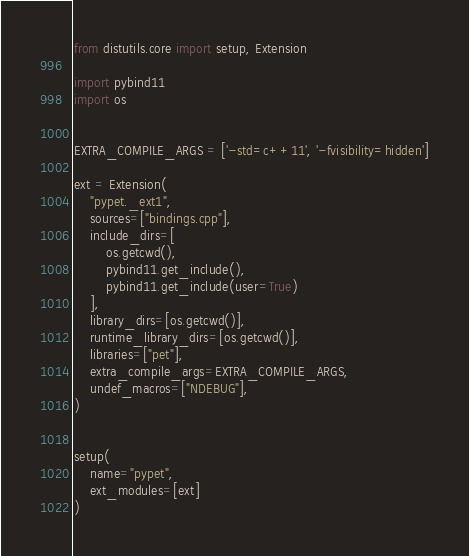Convert code to text. <code><loc_0><loc_0><loc_500><loc_500><_Python_>from distutils.core import setup, Extension

import pybind11
import os


EXTRA_COMPILE_ARGS = ['-std=c++11', '-fvisibility=hidden']

ext = Extension(
    "pypet._ext1",
    sources=["bindings.cpp"],
    include_dirs=[
        os.getcwd(),
        pybind11.get_include(),
        pybind11.get_include(user=True)
    ],
    library_dirs=[os.getcwd()],
    runtime_library_dirs=[os.getcwd()],
    libraries=["pet"],
    extra_compile_args=EXTRA_COMPILE_ARGS,
    undef_macros=["NDEBUG"],
)


setup(
    name="pypet",
    ext_modules=[ext]
)
</code> 